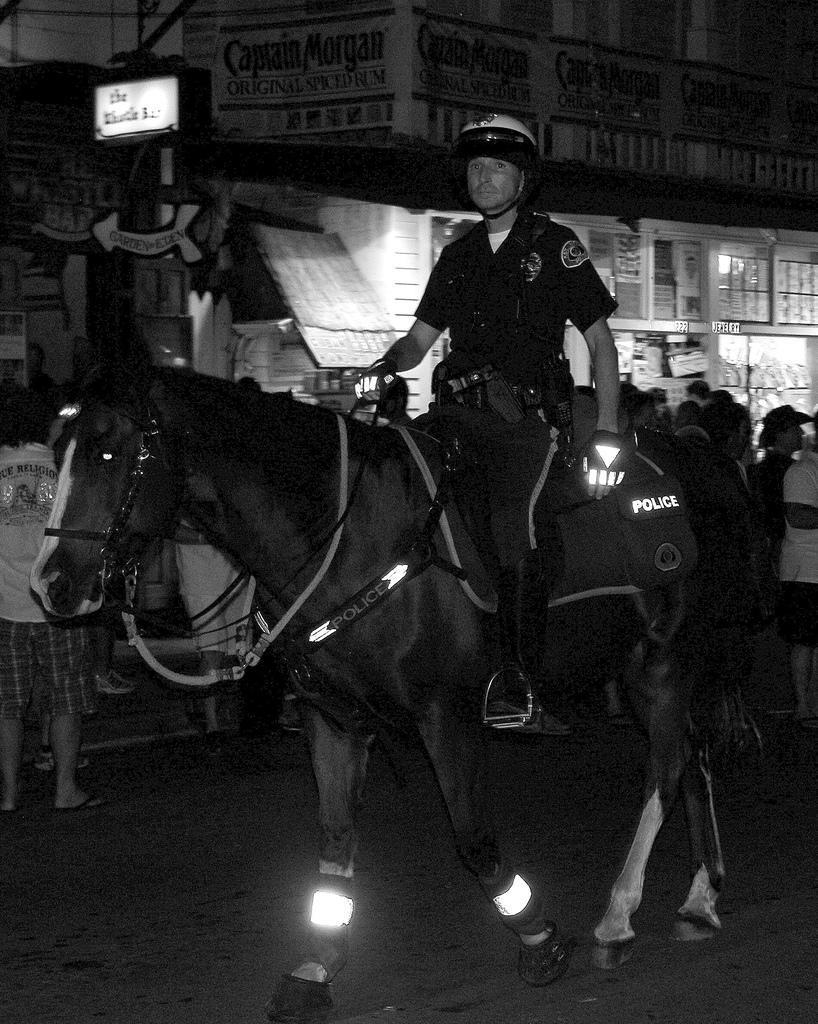In one or two sentences, can you explain what this image depicts? The image is outside of the city. In the image there is a man sitting on horse and riding it. In background we can see a group of people standing and walking and also a buildings,hoarding a window which is closed. 